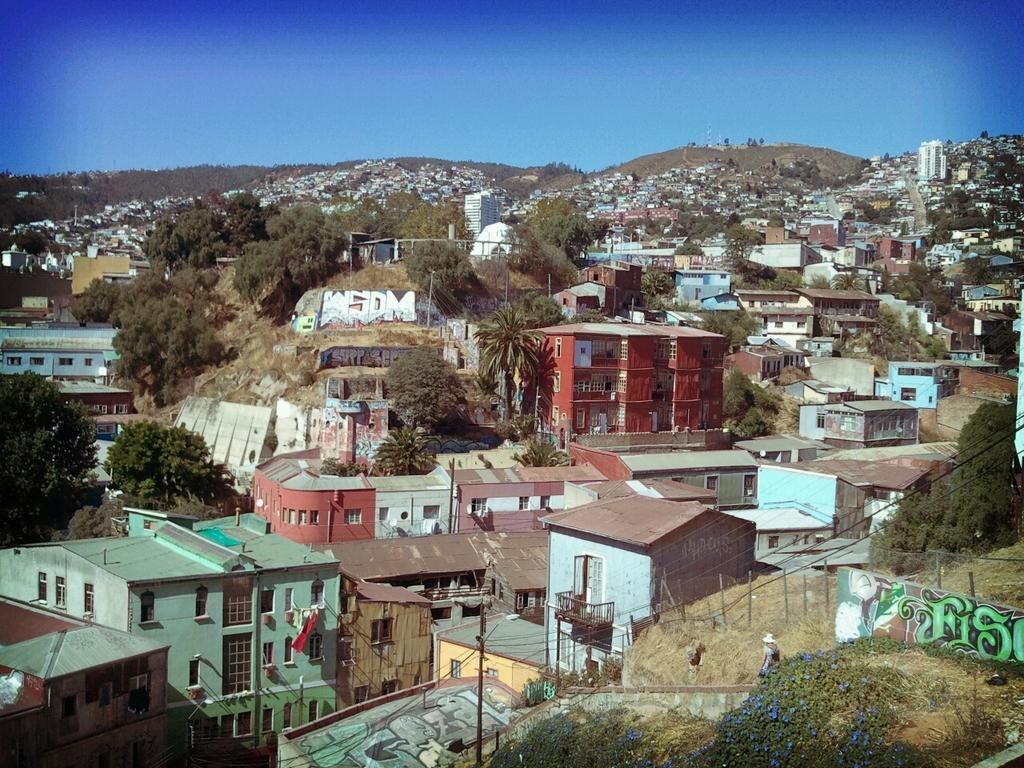Describe this image in one or two sentences. In this image we can see there are buildings, trees, utility poles, grass, mountains and the sky. 